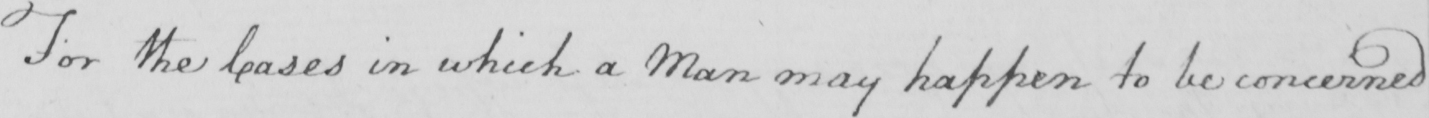What is written in this line of handwriting? For the Cases in which a Man may happen to be concerned 